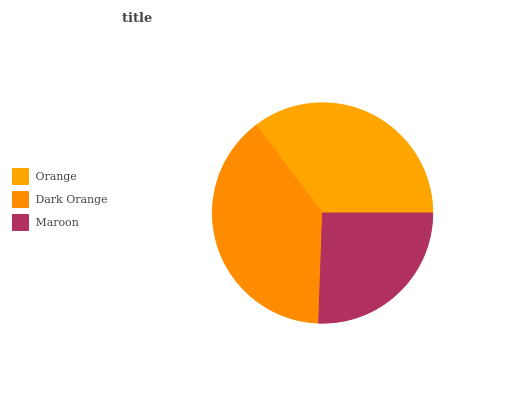Is Maroon the minimum?
Answer yes or no. Yes. Is Dark Orange the maximum?
Answer yes or no. Yes. Is Dark Orange the minimum?
Answer yes or no. No. Is Maroon the maximum?
Answer yes or no. No. Is Dark Orange greater than Maroon?
Answer yes or no. Yes. Is Maroon less than Dark Orange?
Answer yes or no. Yes. Is Maroon greater than Dark Orange?
Answer yes or no. No. Is Dark Orange less than Maroon?
Answer yes or no. No. Is Orange the high median?
Answer yes or no. Yes. Is Orange the low median?
Answer yes or no. Yes. Is Maroon the high median?
Answer yes or no. No. Is Dark Orange the low median?
Answer yes or no. No. 